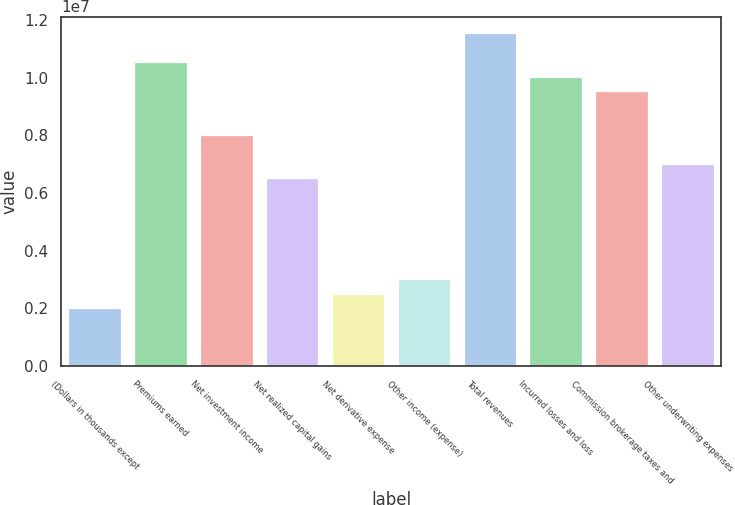Convert chart. <chart><loc_0><loc_0><loc_500><loc_500><bar_chart><fcel>(Dollars in thousands except<fcel>Premiums earned<fcel>Net investment income<fcel>Net realized capital gains<fcel>Net derivative expense<fcel>Other income (expense)<fcel>Total revenues<fcel>Incurred losses and loss<fcel>Commission brokerage taxes and<fcel>Other underwriting expenses<nl><fcel>2.00701e+06<fcel>1.05368e+07<fcel>8.028e+06<fcel>6.52276e+06<fcel>2.50876e+06<fcel>3.01051e+06<fcel>1.15403e+07<fcel>1.0035e+07<fcel>9.53325e+06<fcel>7.0245e+06<nl></chart> 